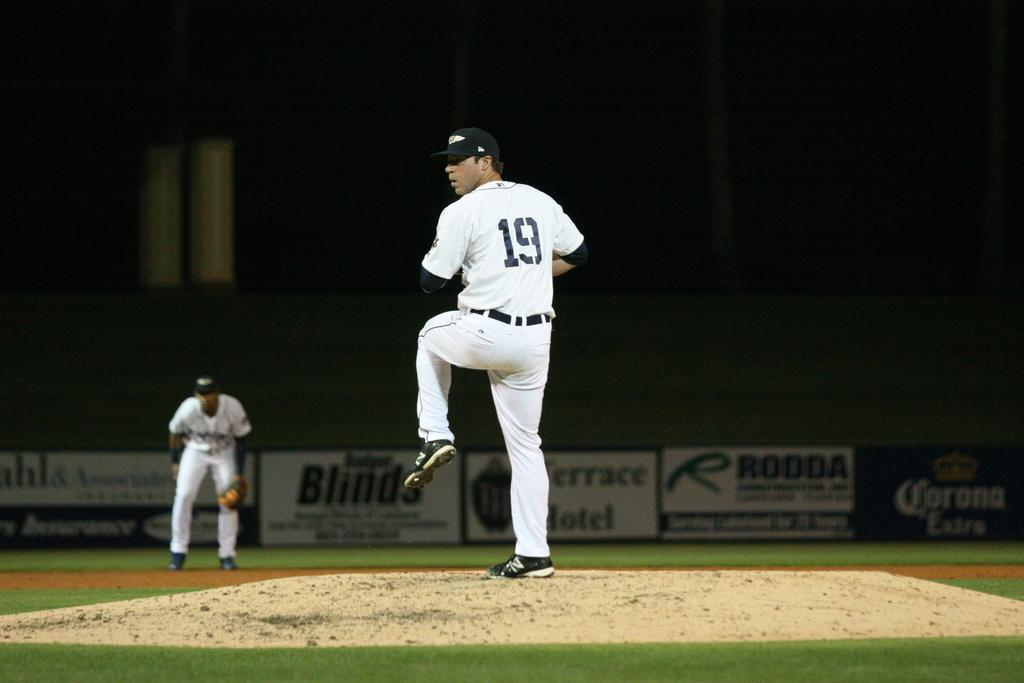<image>
Provide a brief description of the given image. Number 19 is displayed on the jersey of the player on the mound. 